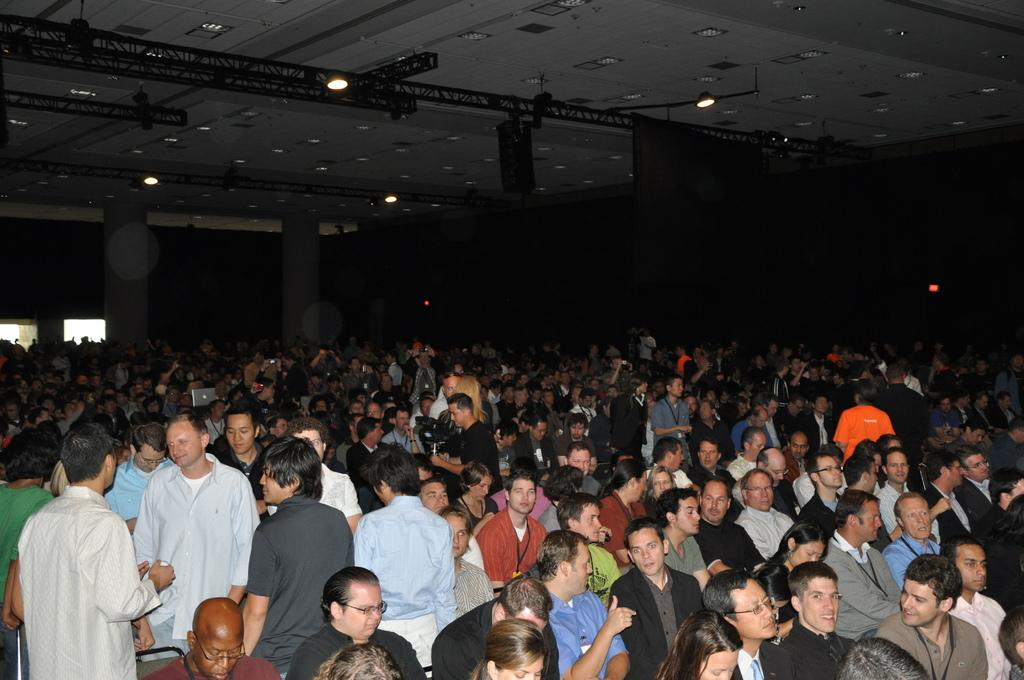What is the main activity of the people in the image? The people in the image are either standing or sitting on chairs. Can you describe the setting in which the people are located? There is a wall and windows in the image, suggesting an indoor setting. What can be seen illuminating the area in the image? There are lights in the image. What type of meat is being served on a platter in the image? There is no meat or platter present in the image. Can you tell me how many thumbs are visible in the image? Thumbs are not mentioned or visible in the image. 